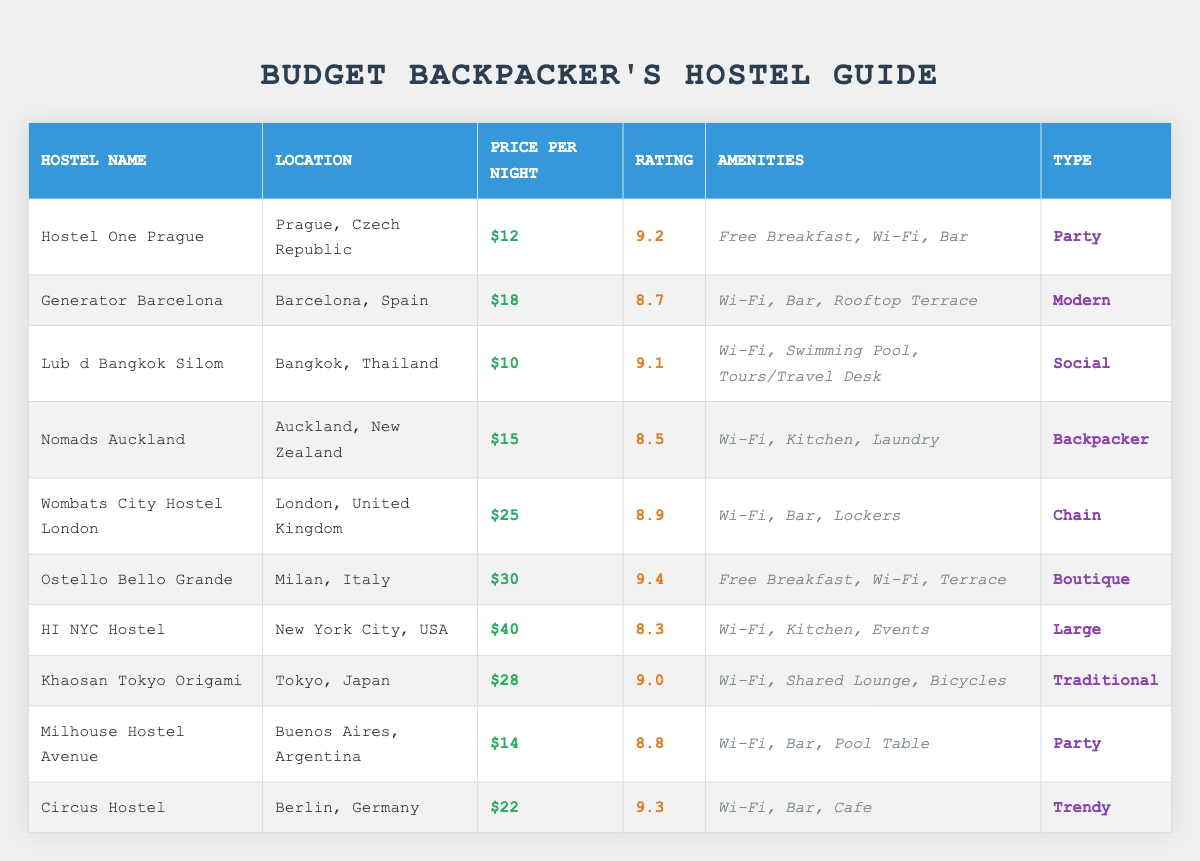What is the price per night at Hostel One Prague? The table lists Hostel One Prague under the 'Hostel Name' column, where the corresponding 'Price per Night' is shown as $12.
Answer: $12 Which hostel has the highest rating? By scanning the 'Rating' column, Ostello Bello Grande shows a rating of 9.4, which is the highest compared to other hostels listed.
Answer: Ostello Bello Grande Is there a hostel in Bangkok with Wi-Fi? Lub d Bangkok Silom, located in Bangkok, Thailand, has Wi-Fi listed under 'Amenities,' indicating it offers this service.
Answer: Yes What is the average price per night for all hostels listed? The prices per night for the hostels are $12, $18, $10, $15, $25, $30, $40, $28, $14, and $22. Summing these prices gives: 12 + 18 + 10 + 15 + 25 + 30 + 40 + 28 + 14 + 22 =  14. The total number of hostels is 10. The average price is  14/10 = $18. The final average price is $18.
Answer: $18 Which hostel in Europe is the most affordable? To find the most affordable hostel in Europe, I look through the entries for European cities (Prague, Barcelona, Milan, London, Berlin). The prices are $12 for Prague, $18 for Barcelona, $30 for Milan, $25 for London, and $22 for Berlin. Here, Hostel One Prague at $12 is the cheapest.
Answer: Hostel One Prague What amenities does the hostel with the lowest price offer? The hostel with the lowest price per night is Lub d Bangkok Silom at $10. Looking at its 'Amenities' column, it offers Wi-Fi, a Swimming Pool, and Tours/Travel Desk.
Answer: Wi-Fi, Swimming Pool, Tours/Travel Desk Are there any hostels rated above 9.0? Checking the 'Rating' column, the following hostels have ratings above 9.0: Hostel One Prague (9.2), Lub d Bangkok Silom (9.1), Ostello Bello Grande (9.4), Khaosan Tokyo Origami (9.0), and Circus Hostel (9.3). Therefore, there are 5 hostels that meet this criterion.
Answer: Yes What is the difference in price per night between the most expensive and least expensive hostels? The most expensive hostel is HI NYC Hostel at $40, and the least expensive is Lub d Bangkok Silom at $10. The difference is $40 - $10 = $30.
Answer: $30 